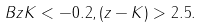<formula> <loc_0><loc_0><loc_500><loc_500>B z K < - 0 . 2 , ( z - K ) > 2 . 5 .</formula> 